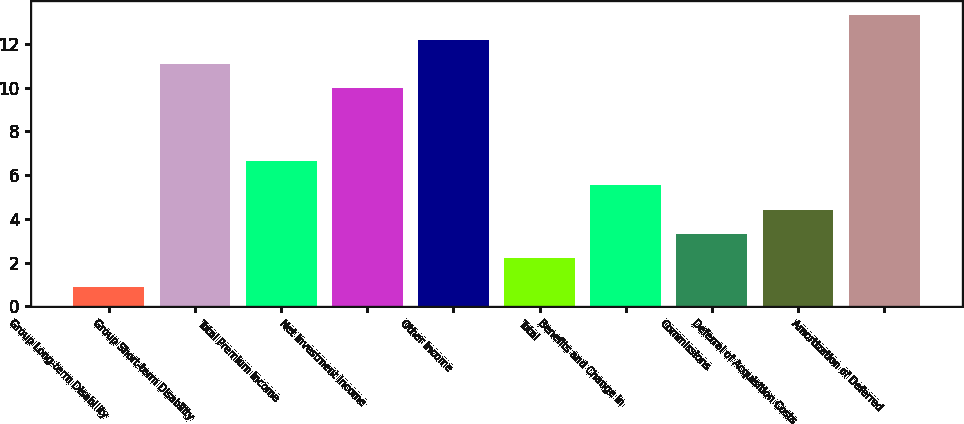<chart> <loc_0><loc_0><loc_500><loc_500><bar_chart><fcel>Group Long-term Disability<fcel>Group Short-term Disability<fcel>Total Premium Income<fcel>Net Investment Income<fcel>Other Income<fcel>Total<fcel>Benefits and Change in<fcel>Commissions<fcel>Deferral of Acquisition Costs<fcel>Amortization of Deferred<nl><fcel>0.9<fcel>11.08<fcel>6.64<fcel>9.97<fcel>12.19<fcel>2.2<fcel>5.53<fcel>3.31<fcel>4.42<fcel>13.3<nl></chart> 